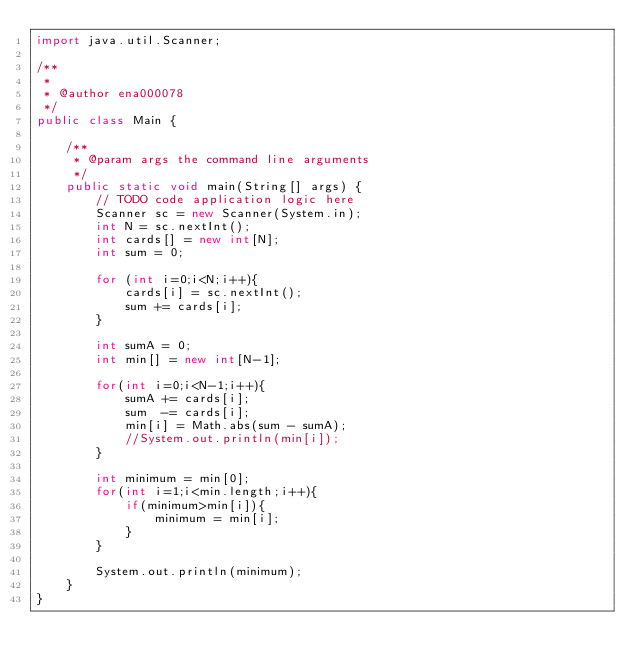Convert code to text. <code><loc_0><loc_0><loc_500><loc_500><_Java_>import java.util.Scanner;

/**
 *
 * @author ena000078
 */
public class Main {

    /**
     * @param args the command line arguments
     */
    public static void main(String[] args) {
        // TODO code application logic here
        Scanner sc = new Scanner(System.in);
        int N = sc.nextInt();
        int cards[] = new int[N];
        int sum = 0;
        
        for (int i=0;i<N;i++){
            cards[i] = sc.nextInt();
            sum += cards[i];
        }
        
        int sumA = 0;
        int min[] = new int[N-1];
        
        for(int i=0;i<N-1;i++){
            sumA += cards[i];
            sum  -= cards[i];
            min[i] = Math.abs(sum - sumA);
            //System.out.println(min[i]);
        }
        
        int minimum = min[0];
        for(int i=1;i<min.length;i++){
            if(minimum>min[i]){
                minimum = min[i];
            }
        }
        
        System.out.println(minimum);
    }
}
</code> 